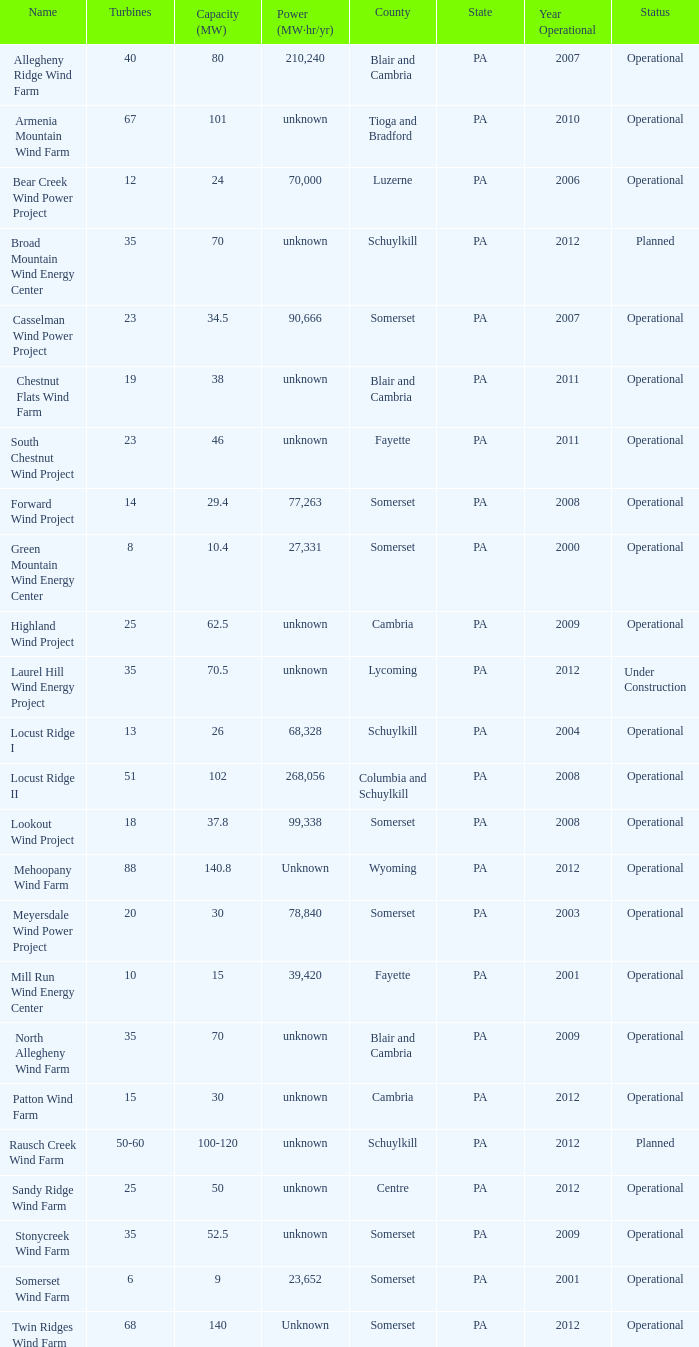What all capacities have turbines between 50-60? 100-120. 